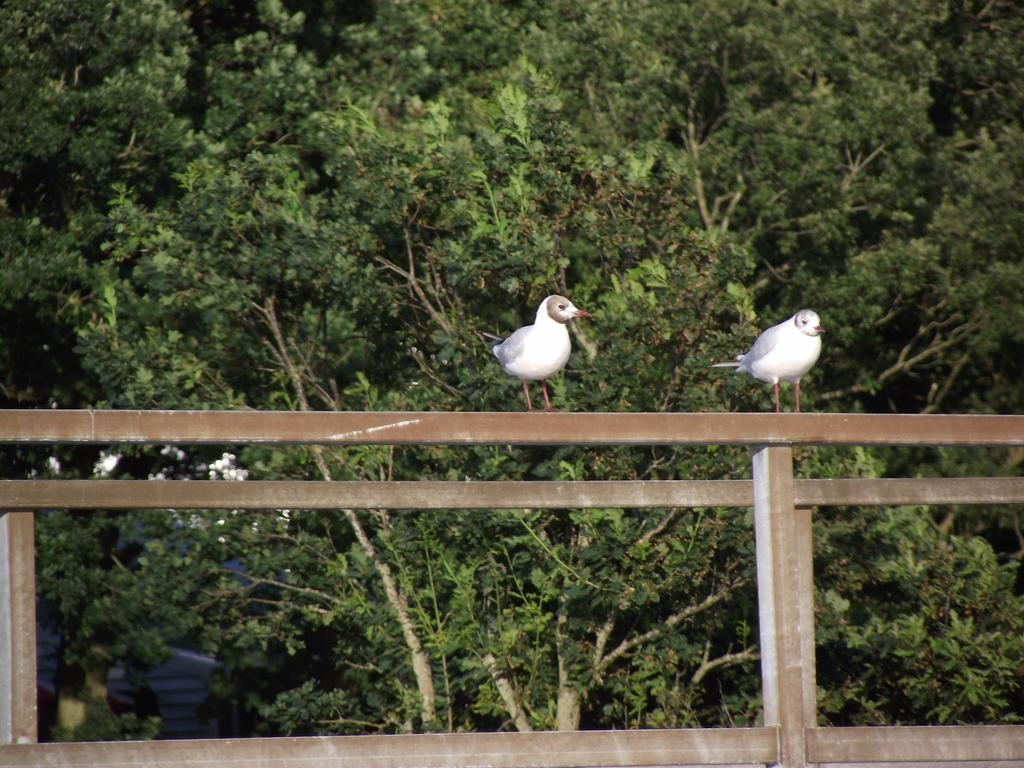How many birds can be seen in the image? There are two birds in the image. What color are the birds? The birds are white in color. Where are the birds located in the image? The birds are on a wooden railing. What can be seen in the background of the image? There are trees in the background of the image. What type of butter is being used by the doll in the image? There is no doll or butter present in the image; it features two white birds on a wooden railing with trees in the background. 